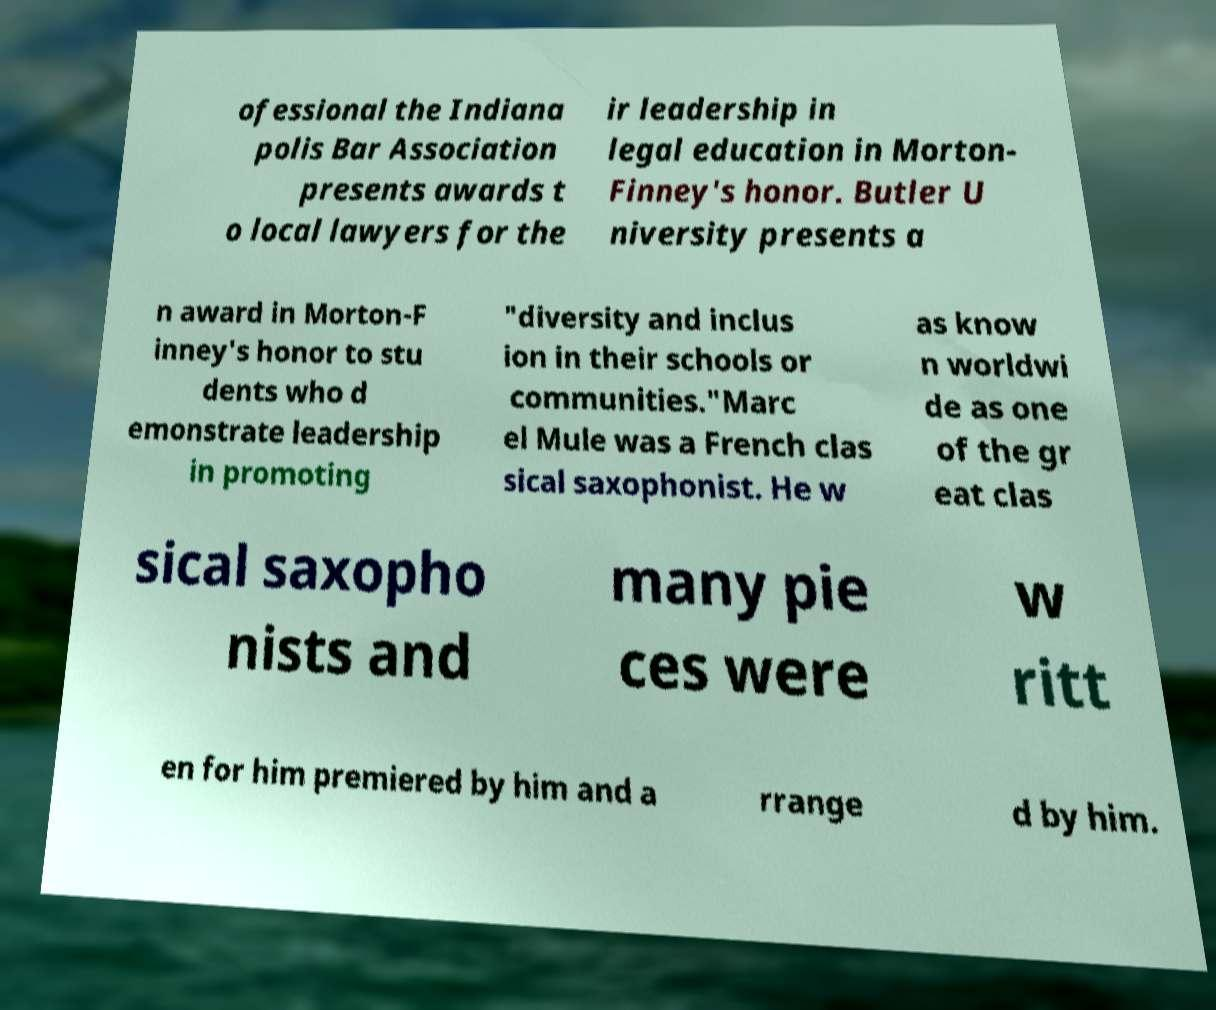Can you read and provide the text displayed in the image?This photo seems to have some interesting text. Can you extract and type it out for me? ofessional the Indiana polis Bar Association presents awards t o local lawyers for the ir leadership in legal education in Morton- Finney's honor. Butler U niversity presents a n award in Morton-F inney's honor to stu dents who d emonstrate leadership in promoting "diversity and inclus ion in their schools or communities."Marc el Mule was a French clas sical saxophonist. He w as know n worldwi de as one of the gr eat clas sical saxopho nists and many pie ces were w ritt en for him premiered by him and a rrange d by him. 